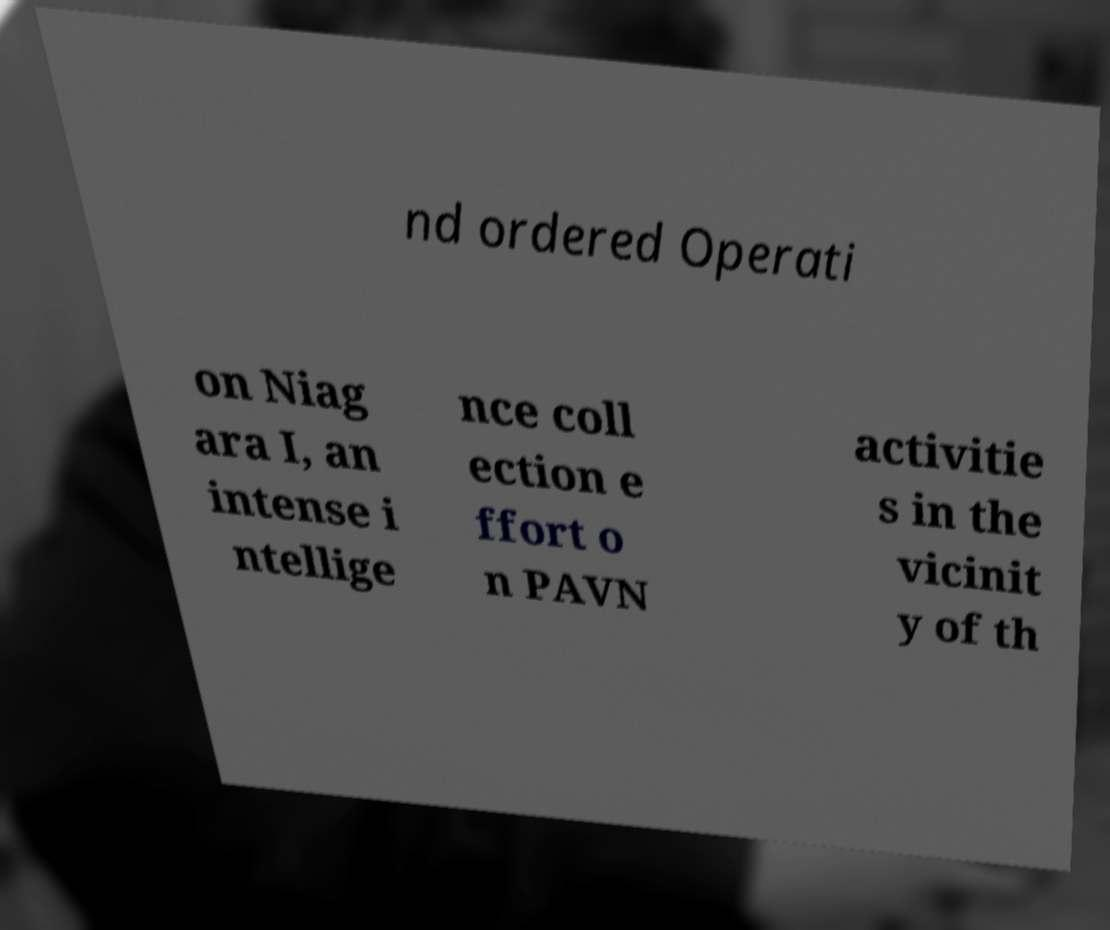Could you assist in decoding the text presented in this image and type it out clearly? nd ordered Operati on Niag ara I, an intense i ntellige nce coll ection e ffort o n PAVN activitie s in the vicinit y of th 